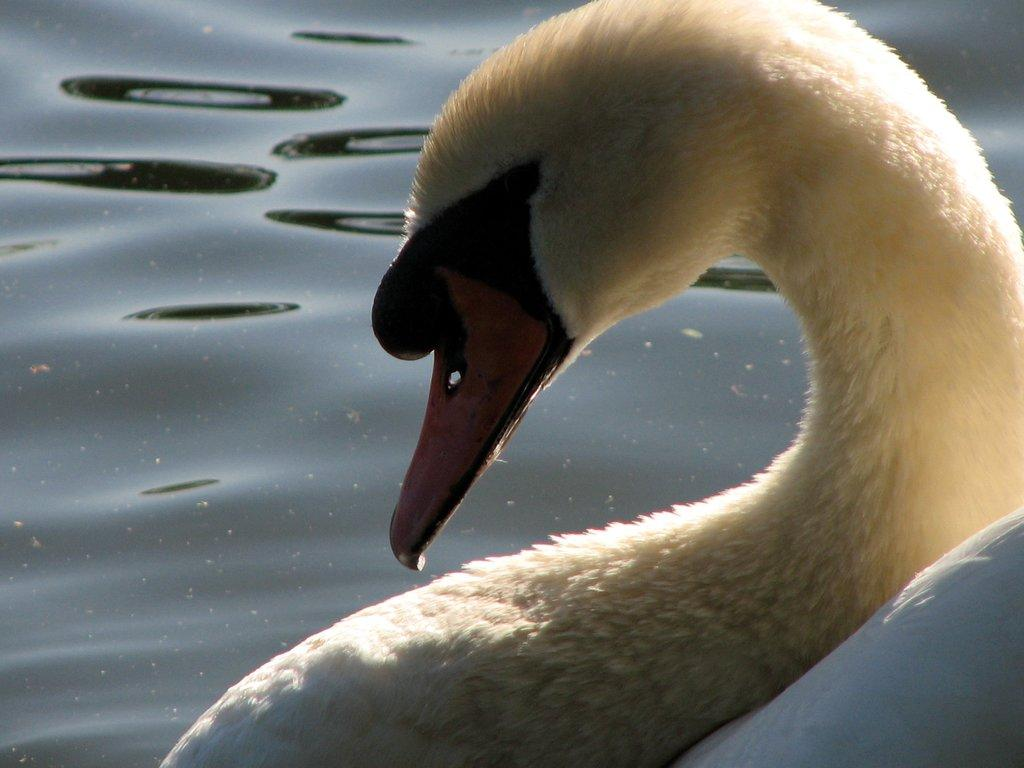What animal is in the picture? There is a swan in the picture. What is behind the swan? There is water behind the swan. What type of maid is standing next to the swan in the picture? There is no maid present in the picture; it only features a swan and water. 